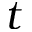Convert formula to latex. <formula><loc_0><loc_0><loc_500><loc_500>t</formula> 